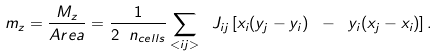Convert formula to latex. <formula><loc_0><loc_0><loc_500><loc_500>m _ { z } = \frac { M _ { z } } { A r e a } = \frac { 1 } { 2 \ n _ { c e l l s } } \sum _ { < i j > } \ J _ { i j } \left [ x _ { i } ( y _ { j } - y _ { i } ) \ - \ y _ { i } ( x _ { j } - x _ { i } ) \right ] .</formula> 